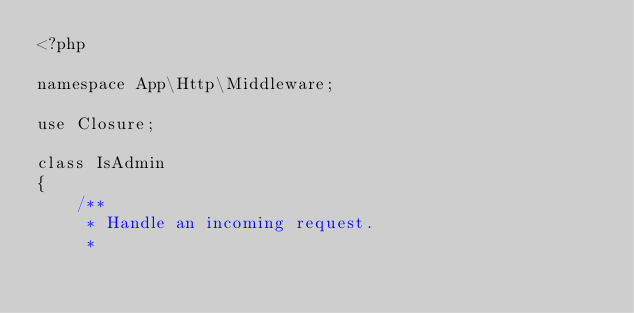Convert code to text. <code><loc_0><loc_0><loc_500><loc_500><_PHP_><?php

namespace App\Http\Middleware;

use Closure;

class IsAdmin
{
    /**
     * Handle an incoming request.
     *</code> 